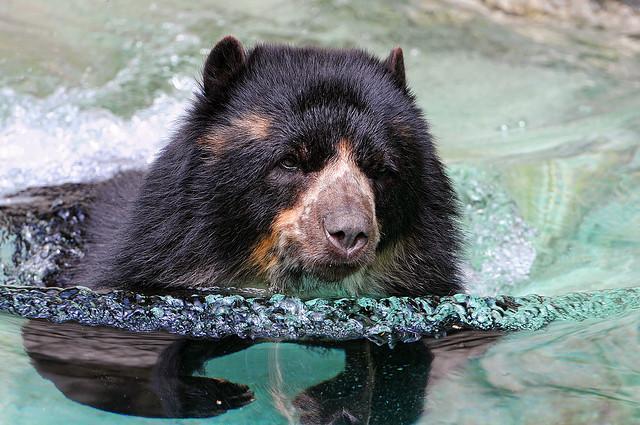How many young girls are pictured?
Give a very brief answer. 0. 